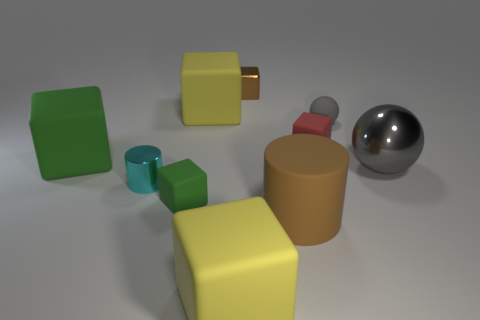There is a object that is the same color as the tiny sphere; what is its size?
Give a very brief answer. Large. There is a cyan cylinder; what number of big rubber blocks are in front of it?
Give a very brief answer. 1. Are the brown thing in front of the brown metallic object and the small red object made of the same material?
Offer a very short reply. Yes. What is the color of the large rubber thing that is the same shape as the cyan metallic thing?
Ensure brevity in your answer.  Brown. There is a tiny green object; what shape is it?
Your answer should be very brief. Cube. What number of objects are tiny green rubber things or tiny matte objects?
Make the answer very short. 3. Do the tiny block in front of the big metal thing and the big thing that is on the left side of the small metal cylinder have the same color?
Keep it short and to the point. Yes. How many other objects are the same shape as the tiny gray rubber object?
Provide a succinct answer. 1. Are any tiny yellow blocks visible?
Provide a succinct answer. No. What number of objects are either red matte cubes or yellow rubber cubes in front of the small gray ball?
Keep it short and to the point. 2. 